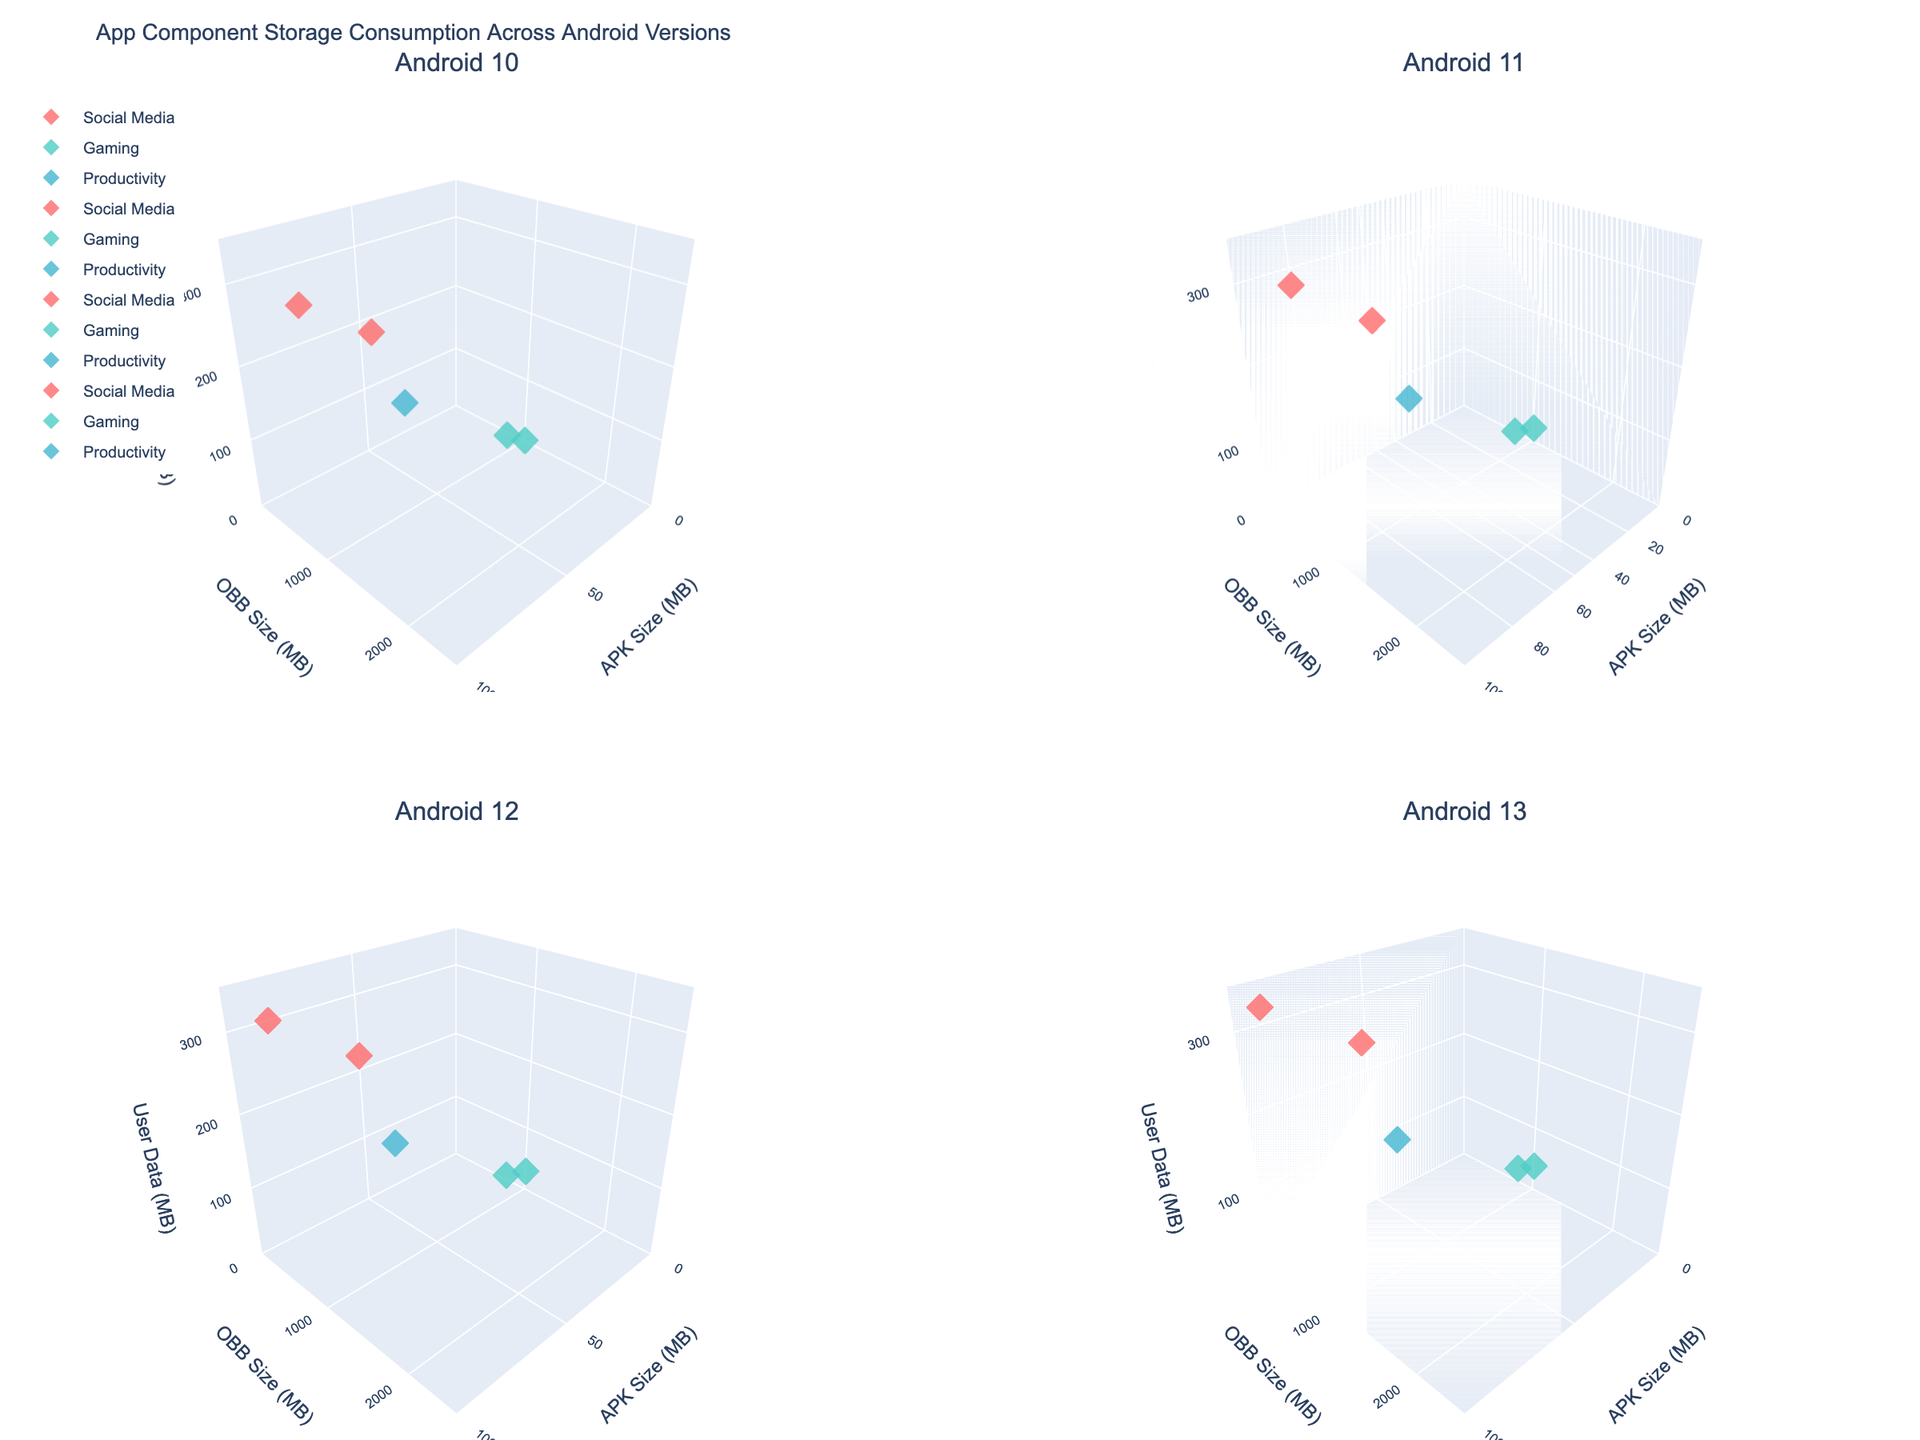What is the title of the figure? The title is located at the top of the figure, above all the subplots.
Answer: App Component Storage Consumption Across Android Versions How many OS versions are represented in the figure? There are four subplots in the figure, each representing a different OS version.
Answer: 4 Which app category appears to have the largest data points for OBB Size (MB)? Looking at the scatter points in each subplot, the app category represented by the largest y-axis values (OBB Size) is Gaming.
Answer: Gaming What are the axis titles for each subplot? All subplots have the same axis titles: "APK Size (MB)" for the x-axis, "OBB Size (MB)" for the y-axis, and "User Data (MB)" for the z-axis.
Answer: APK Size (MB), OBB Size (MB), User Data (MB) Which app has the highest User Data (MB) across all OS versions, and how much is it? The data point with the highest z-value (User Data) across all subplots belongs to Facebook under Android 13 with 320 MB.
Answer: Facebook, 320 MB How does the APK size of Facebook change from Android 10 to Android 12? By comparing the x-values of Facebook's data points in the subplots for Android 10 and Android 12, the APK size increases from 75 MB to 85 MB.
Answer: Increases from 75 MB to 85 MB Which app category exhibits a consistent increase in User Data (MB) across all OS versions? Examining the z-values (User Data) across all subplots, the Social Media category consistently shows higher User Data for each subsequent OS version.
Answer: Social Media Between Android 10 and Android 13, which app has the smallest increase in APK size, and what is the difference? By comparing the x-values (APK Size) across subplots for each app, Instagram has the smallest increase in APK size, from 45 MB to 52 MB, a difference of 7 MB.
Answer: Instagram, 7 MB For Android 12, which app has the largest combined size of APK and OBB, and how much is the total? In the Android 12 subplot, the app with the largest summation of x and y values (APK + OBB) is Call of Duty Mobile with a combined size of 2260 MB.
Answer: Call of Duty Mobile, 2260 MB What trend can be observed for the OBB size of Call of Duty Mobile from Android 10 to Android 13? Observing the y-values for Call of Duty Mobile across the subplots shows a consistent increase in OBB size from 2000 MB to 2300 MB.
Answer: Consistent increase 